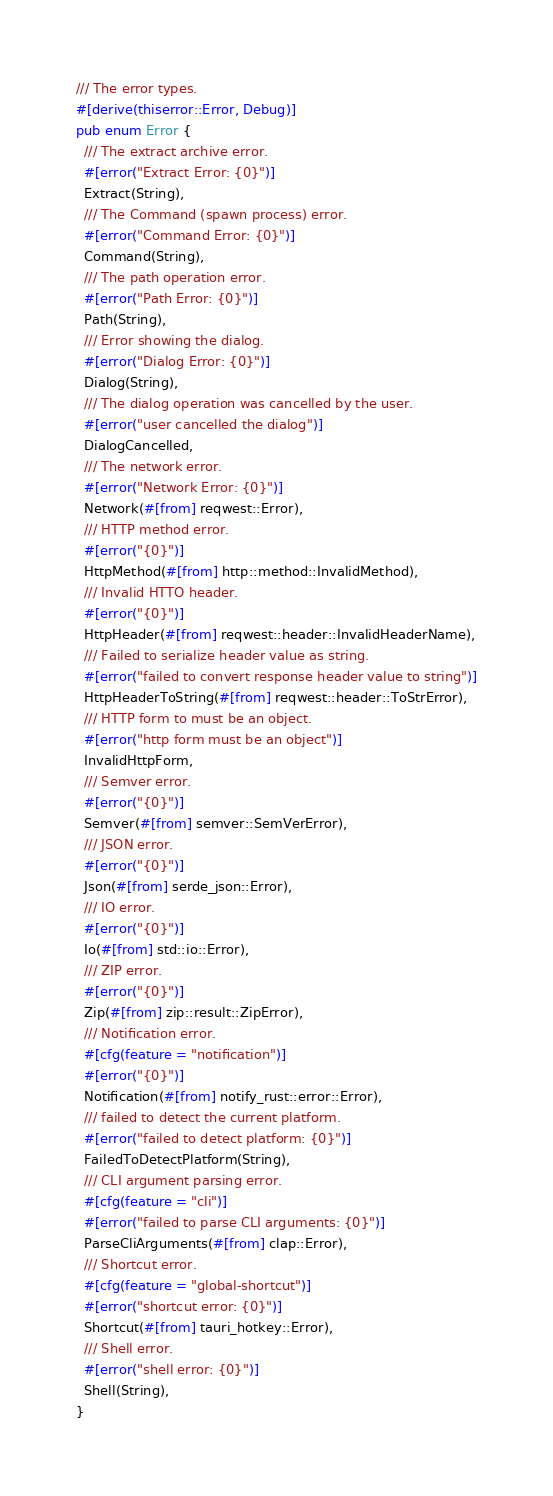<code> <loc_0><loc_0><loc_500><loc_500><_Rust_>/// The error types.
#[derive(thiserror::Error, Debug)]
pub enum Error {
  /// The extract archive error.
  #[error("Extract Error: {0}")]
  Extract(String),
  /// The Command (spawn process) error.
  #[error("Command Error: {0}")]
  Command(String),
  /// The path operation error.
  #[error("Path Error: {0}")]
  Path(String),
  /// Error showing the dialog.
  #[error("Dialog Error: {0}")]
  Dialog(String),
  /// The dialog operation was cancelled by the user.
  #[error("user cancelled the dialog")]
  DialogCancelled,
  /// The network error.
  #[error("Network Error: {0}")]
  Network(#[from] reqwest::Error),
  /// HTTP method error.
  #[error("{0}")]
  HttpMethod(#[from] http::method::InvalidMethod),
  /// Invalid HTTO header.
  #[error("{0}")]
  HttpHeader(#[from] reqwest::header::InvalidHeaderName),
  /// Failed to serialize header value as string.
  #[error("failed to convert response header value to string")]
  HttpHeaderToString(#[from] reqwest::header::ToStrError),
  /// HTTP form to must be an object.
  #[error("http form must be an object")]
  InvalidHttpForm,
  /// Semver error.
  #[error("{0}")]
  Semver(#[from] semver::SemVerError),
  /// JSON error.
  #[error("{0}")]
  Json(#[from] serde_json::Error),
  /// IO error.
  #[error("{0}")]
  Io(#[from] std::io::Error),
  /// ZIP error.
  #[error("{0}")]
  Zip(#[from] zip::result::ZipError),
  /// Notification error.
  #[cfg(feature = "notification")]
  #[error("{0}")]
  Notification(#[from] notify_rust::error::Error),
  /// failed to detect the current platform.
  #[error("failed to detect platform: {0}")]
  FailedToDetectPlatform(String),
  /// CLI argument parsing error.
  #[cfg(feature = "cli")]
  #[error("failed to parse CLI arguments: {0}")]
  ParseCliArguments(#[from] clap::Error),
  /// Shortcut error.
  #[cfg(feature = "global-shortcut")]
  #[error("shortcut error: {0}")]
  Shortcut(#[from] tauri_hotkey::Error),
  /// Shell error.
  #[error("shell error: {0}")]
  Shell(String),
}
</code> 